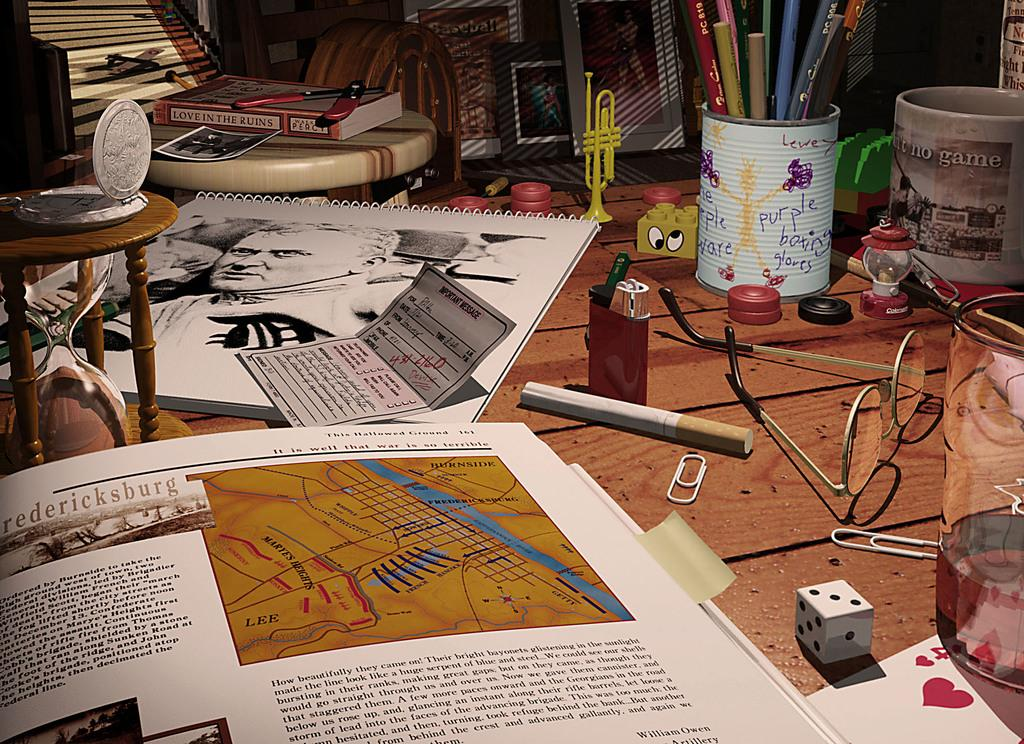What type of furniture is present in the image? There is a table in the image. What items can be seen on the table? There are books, a card, a cigarette, a lighter, a spectacle, a dice, a cup, a pens stand, pens, and a saxophone on the table. How many objects are on the table? There are 12 objects on the table. What type of shirt is hanging on the branch in the image? There is no shirt or branch present in the image. How is the rake being used in the image? There is no rake present in the image. 